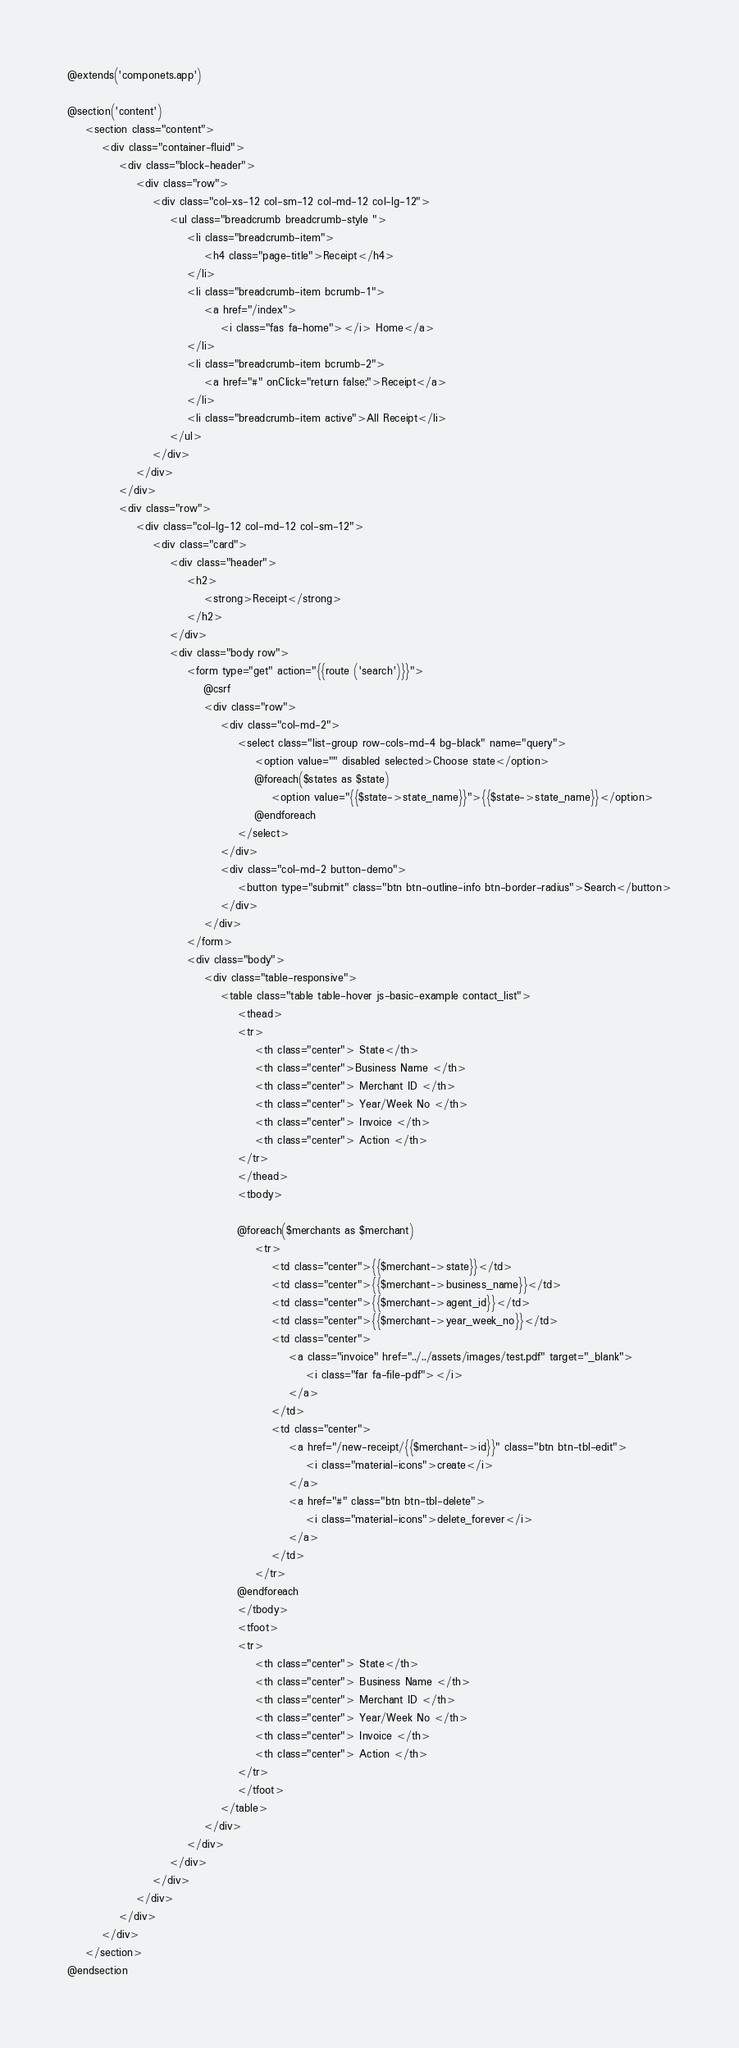Convert code to text. <code><loc_0><loc_0><loc_500><loc_500><_PHP_>@extends('componets.app')

@section('content')
    <section class="content">
        <div class="container-fluid">
            <div class="block-header">
                <div class="row">
                    <div class="col-xs-12 col-sm-12 col-md-12 col-lg-12">
                        <ul class="breadcrumb breadcrumb-style ">
                            <li class="breadcrumb-item">
                                <h4 class="page-title">Receipt</h4>
                            </li>
                            <li class="breadcrumb-item bcrumb-1">
                                <a href="/index">
                                    <i class="fas fa-home"></i> Home</a>
                            </li>
                            <li class="breadcrumb-item bcrumb-2">
                                <a href="#" onClick="return false;">Receipt</a>
                            </li>
                            <li class="breadcrumb-item active">All Receipt</li>
                        </ul>
                    </div>
                </div>
            </div>
            <div class="row">
                <div class="col-lg-12 col-md-12 col-sm-12">
                    <div class="card">
                        <div class="header">
                            <h2>
                                <strong>Receipt</strong>
                            </h2>
                        </div>
                        <div class="body row">
                            <form type="get" action="{{route ('search')}}">
                                @csrf
                                <div class="row">
                                    <div class="col-md-2">
                                        <select class="list-group row-cols-md-4 bg-black" name="query">
                                            <option value="" disabled selected>Choose state</option>
                                            @foreach($states as $state)
                                                <option value="{{$state->state_name}}">{{$state->state_name}}</option>
                                            @endforeach
                                        </select>
                                    </div>
                                    <div class="col-md-2 button-demo">
                                        <button type="submit" class="btn btn-outline-info btn-border-radius">Search</button>
                                    </div>
                                </div>
                            </form>
                            <div class="body">
                                <div class="table-responsive">
                                    <table class="table table-hover js-basic-example contact_list">
                                        <thead>
                                        <tr>
                                            <th class="center"> State</th>
                                            <th class="center">Business Name </th>
                                            <th class="center"> Merchant ID </th>
                                            <th class="center"> Year/Week No </th>
                                            <th class="center"> Invoice </th>
                                            <th class="center"> Action </th>
                                        </tr>
                                        </thead>
                                        <tbody>

                                        @foreach($merchants as $merchant)
                                            <tr>
                                                <td class="center">{{$merchant->state}}</td>
                                                <td class="center">{{$merchant->business_name}}</td>
                                                <td class="center">{{$merchant->agent_id}}</td>
                                                <td class="center">{{$merchant->year_week_no}}</td>
                                                <td class="center">
                                                    <a class="invoice" href="../../assets/images/test.pdf" target="_blank">
                                                        <i class="far fa-file-pdf"></i>
                                                    </a>
                                                </td>
                                                <td class="center">
                                                    <a href="/new-receipt/{{$merchant->id}}" class="btn btn-tbl-edit">
                                                        <i class="material-icons">create</i>
                                                    </a>
                                                    <a href="#" class="btn btn-tbl-delete">
                                                        <i class="material-icons">delete_forever</i>
                                                    </a>
                                                </td>
                                            </tr>
                                        @endforeach
                                        </tbody>
                                        <tfoot>
                                        <tr>
                                            <th class="center"> State</th>
                                            <th class="center"> Business Name </th>
                                            <th class="center"> Merchant ID </th>
                                            <th class="center"> Year/Week No </th>
                                            <th class="center"> Invoice </th>
                                            <th class="center"> Action </th>
                                        </tr>
                                        </tfoot>
                                    </table>
                                </div>
                            </div>
                        </div>
                    </div>
                </div>
            </div>
        </div>
    </section>
@endsection
</code> 